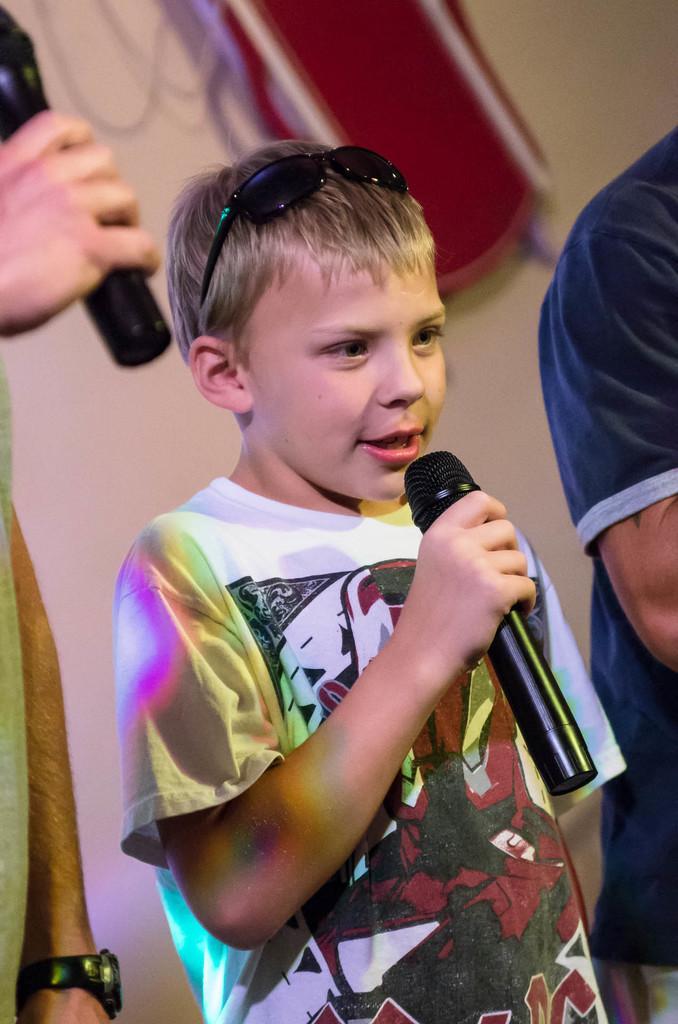Please provide a concise description of this image. In the image we can see there is a kid who is standing and holding mic in his hand and beside him there are other people standing. 